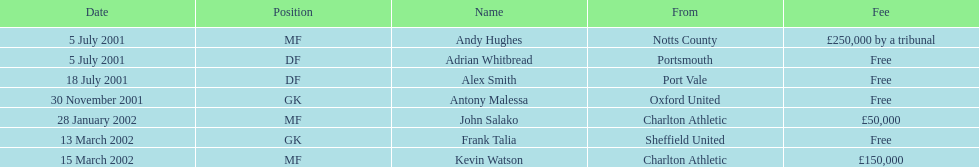Whose name appears last in the chart? Kevin Watson. Help me parse the entirety of this table. {'header': ['Date', 'Position', 'Name', 'From', 'Fee'], 'rows': [['5 July 2001', 'MF', 'Andy Hughes', 'Notts County', '£250,000 by a tribunal'], ['5 July 2001', 'DF', 'Adrian Whitbread', 'Portsmouth', 'Free'], ['18 July 2001', 'DF', 'Alex Smith', 'Port Vale', 'Free'], ['30 November 2001', 'GK', 'Antony Malessa', 'Oxford United', 'Free'], ['28 January 2002', 'MF', 'John Salako', 'Charlton Athletic', '£50,000'], ['13 March 2002', 'GK', 'Frank Talia', 'Sheffield United', 'Free'], ['15 March 2002', 'MF', 'Kevin Watson', 'Charlton Athletic', '£150,000']]} 